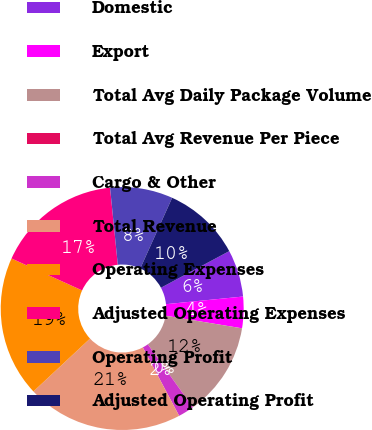Convert chart to OTSL. <chart><loc_0><loc_0><loc_500><loc_500><pie_chart><fcel>Domestic<fcel>Export<fcel>Total Avg Daily Package Volume<fcel>Total Avg Revenue Per Piece<fcel>Cargo & Other<fcel>Total Revenue<fcel>Operating Expenses<fcel>Adjusted Operating Expenses<fcel>Operating Profit<fcel>Adjusted Operating Profit<nl><fcel>6.26%<fcel>4.18%<fcel>12.49%<fcel>0.03%<fcel>2.11%<fcel>20.81%<fcel>18.72%<fcel>16.65%<fcel>8.34%<fcel>10.42%<nl></chart> 